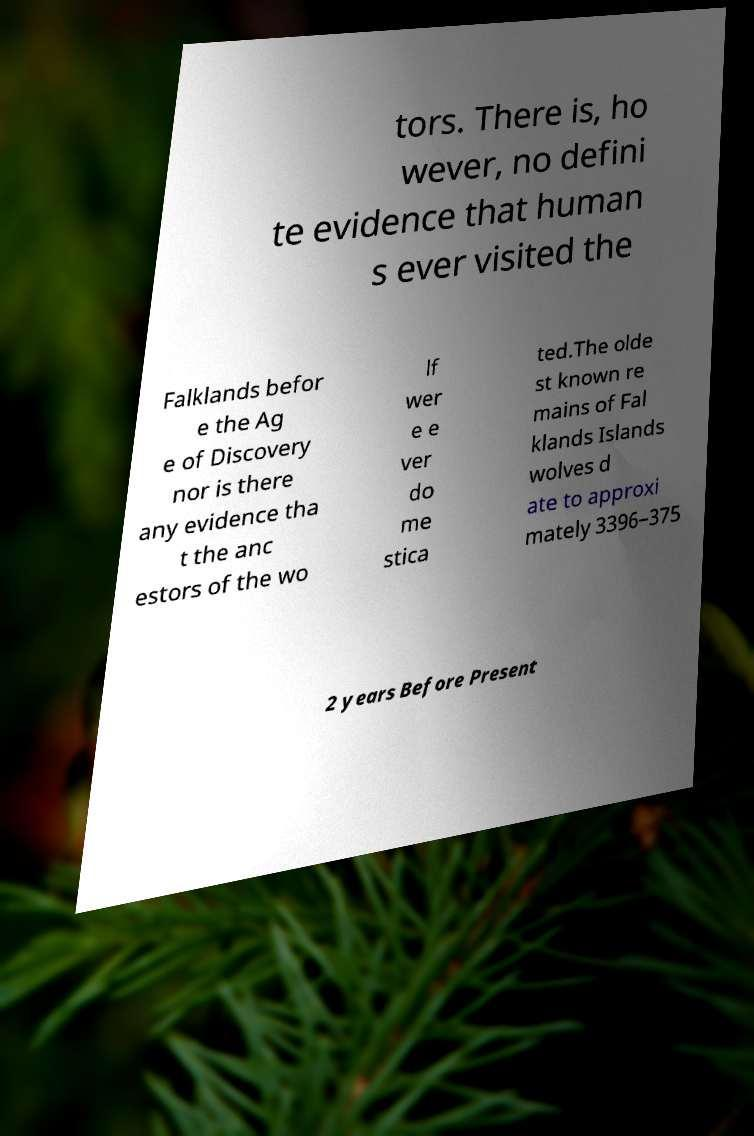Can you accurately transcribe the text from the provided image for me? tors. There is, ho wever, no defini te evidence that human s ever visited the Falklands befor e the Ag e of Discovery nor is there any evidence tha t the anc estors of the wo lf wer e e ver do me stica ted.The olde st known re mains of Fal klands Islands wolves d ate to approxi mately 3396–375 2 years Before Present 